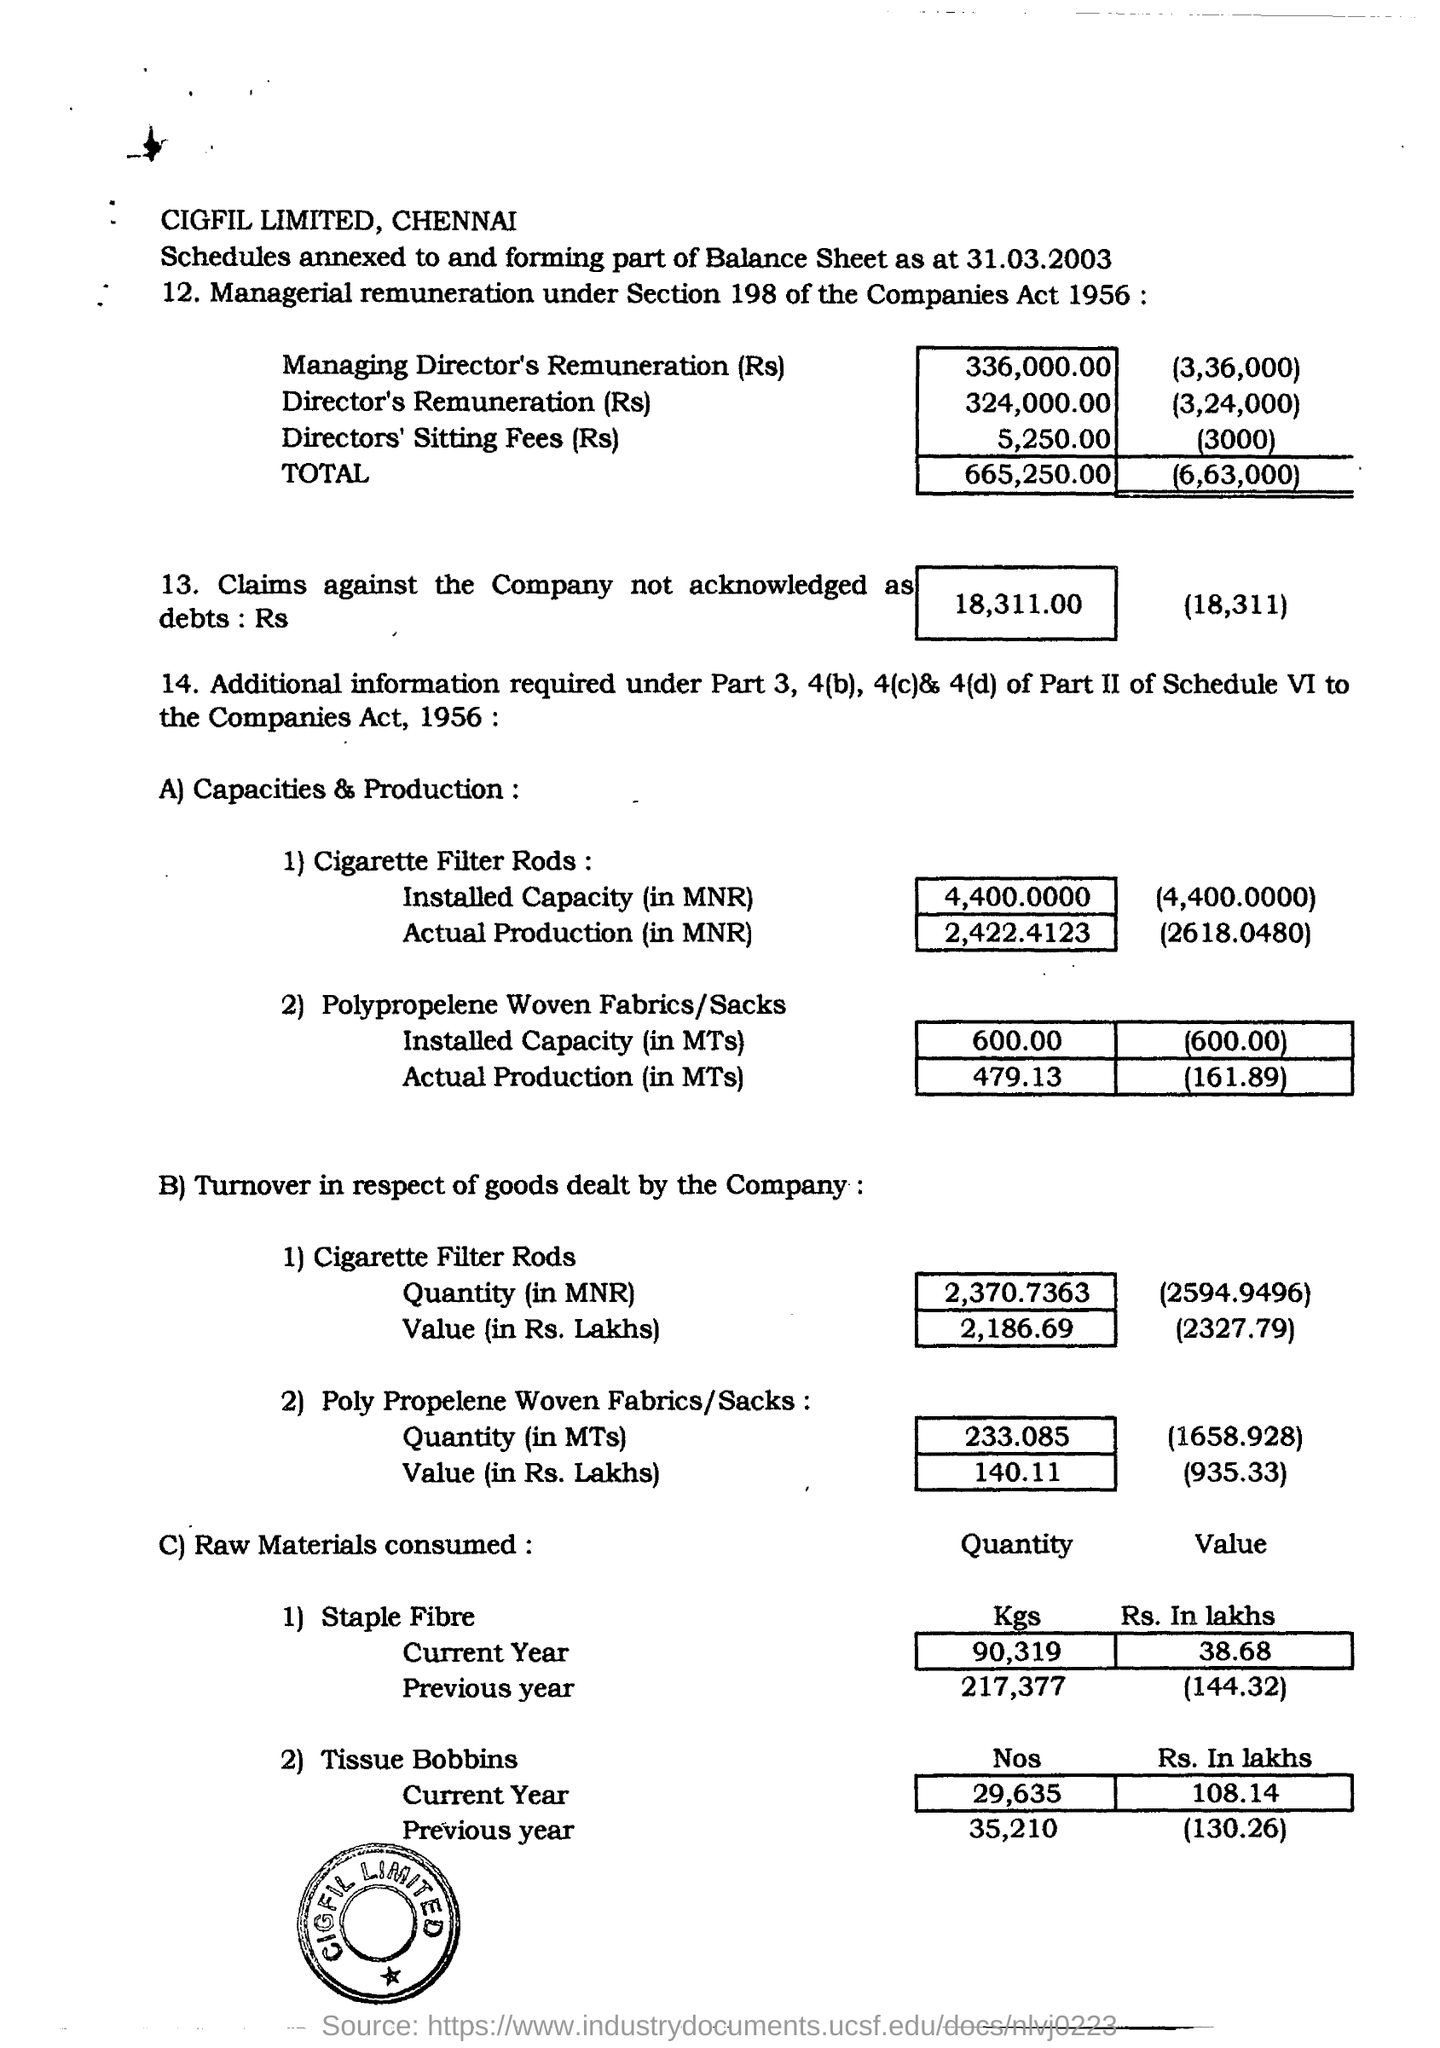How much amount is claimed against the company not acknowledged as debt in rs ?
Provide a short and direct response. 18,311.00. What is the installed capacity (in mnr) in cigarette filter rods ?
Provide a succinct answer. 4,400.0000. What is the actual production (in mnr) in cigarette filter rods ?
Your answer should be very brief. 2,422.4123. What is the number of tissue bobbins used in the current year ?
Your answer should be very brief. 29,635. 